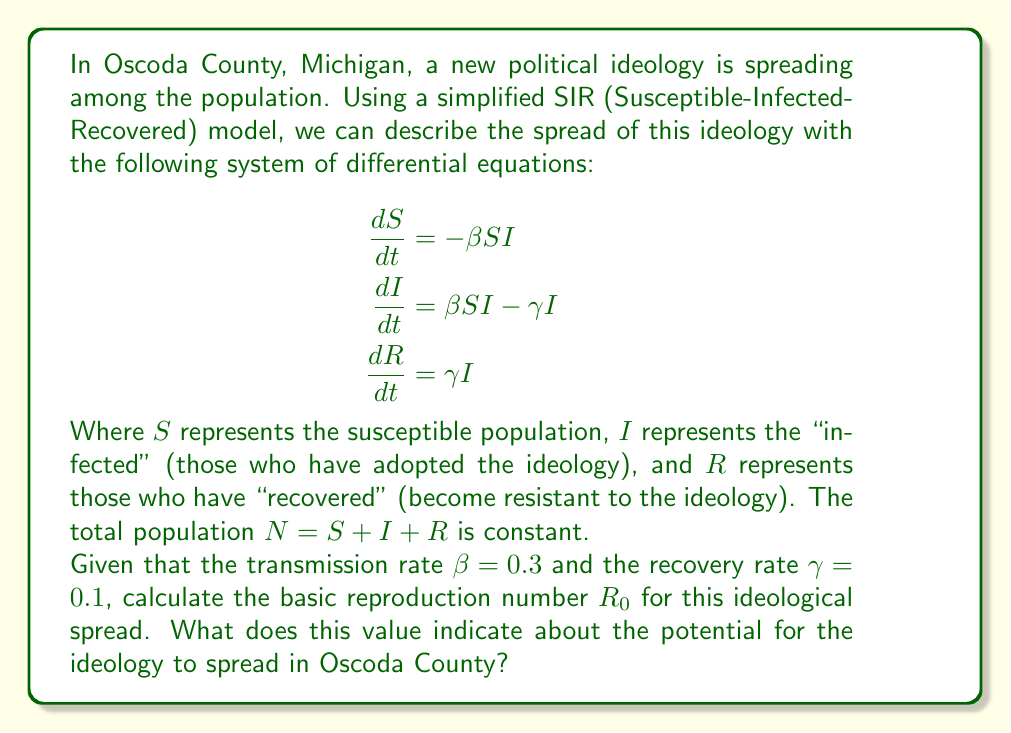What is the answer to this math problem? To solve this problem, we need to understand the concept of the basic reproduction number $R_0$ in epidemiological models and how it applies to the spread of political ideologies.

1. The basic reproduction number $R_0$ is defined as the average number of secondary cases produced by a single infected individual in a completely susceptible population.

2. In the SIR model, $R_0$ is calculated using the formula:

   $$R_0 = \frac{\beta}{\gamma}$$

   Where $\beta$ is the transmission rate and $\gamma$ is the recovery rate.

3. Given the values in the question:
   $\beta = 0.3$ (transmission rate)
   $\gamma = 0.1$ (recovery rate)

4. Let's substitute these values into the formula:

   $$R_0 = \frac{0.3}{0.1} = 3$$

5. Interpretation of $R_0$:
   - If $R_0 > 1$, the ideology is expected to spread in the population.
   - If $R_0 < 1$, the ideology is expected to die out.
   - If $R_0 = 1$, the ideology is expected to become endemic (persist at a constant level).

6. In this case, $R_0 = 3$, which is greater than 1.

This value indicates that, on average, each person who adopts the ideology will spread it to 3 other people before they "recover" (become resistant to the ideology). Since $R_0 > 1$, the ideology has the potential to spread rapidly through the population of Oscoda County if no interventions are implemented.
Answer: The basic reproduction number $R_0 = 3$. This indicates that the ideology has a high potential to spread in Oscoda County, as each person who adopts the ideology is expected to spread it to 3 others before recovering. 